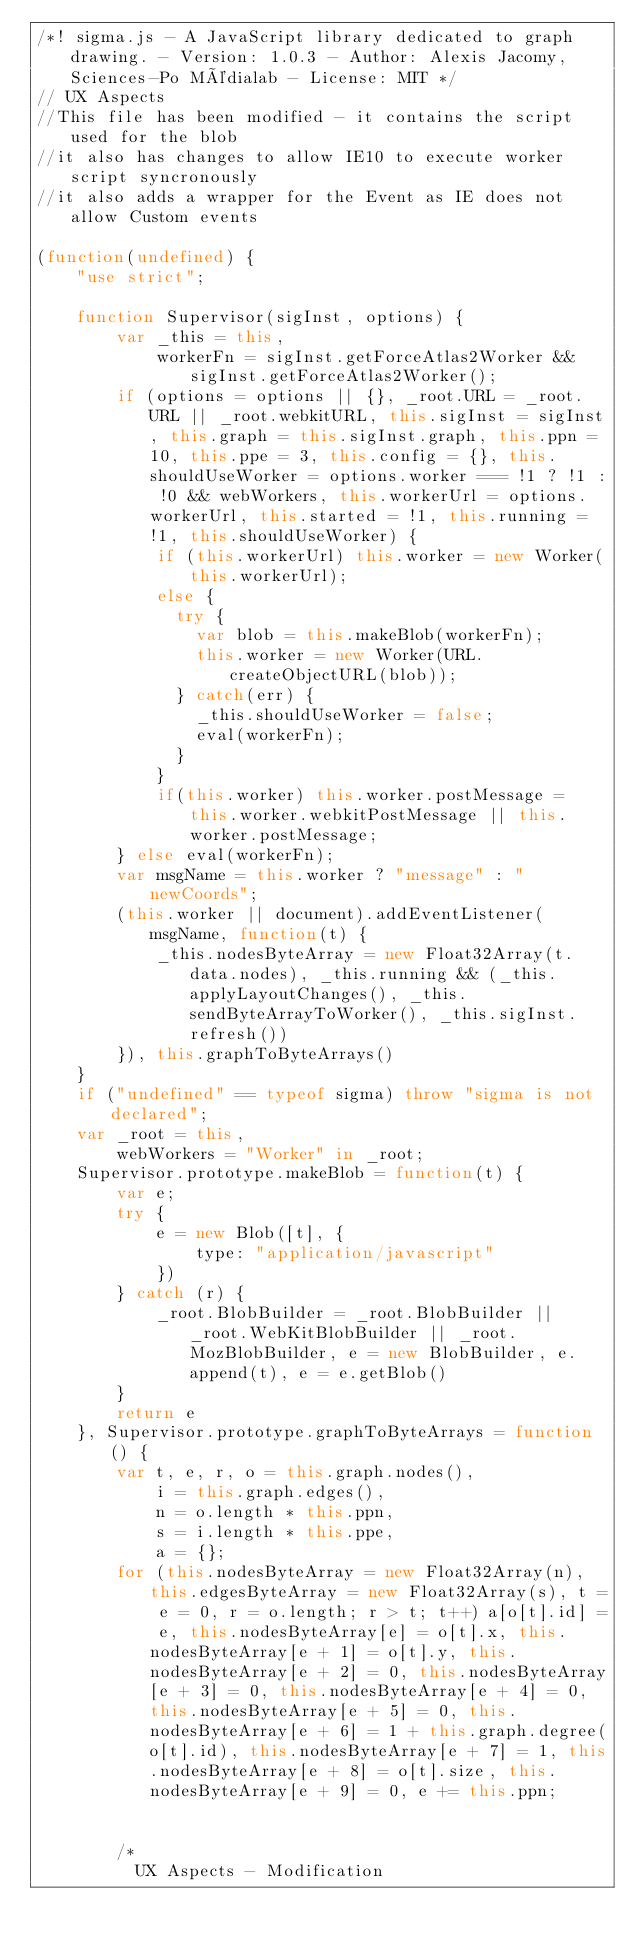<code> <loc_0><loc_0><loc_500><loc_500><_JavaScript_>/*! sigma.js - A JavaScript library dedicated to graph drawing. - Version: 1.0.3 - Author: Alexis Jacomy, Sciences-Po Médialab - License: MIT */
// UX Aspects
//This file has been modified - it contains the script used for the blob
//it also has changes to allow IE10 to execute worker script syncronously
//it also adds a wrapper for the Event as IE does not allow Custom events

(function(undefined) {
    "use strict";

    function Supervisor(sigInst, options) {
        var _this = this,
            workerFn = sigInst.getForceAtlas2Worker && sigInst.getForceAtlas2Worker();
        if (options = options || {}, _root.URL = _root.URL || _root.webkitURL, this.sigInst = sigInst, this.graph = this.sigInst.graph, this.ppn = 10, this.ppe = 3, this.config = {}, this.shouldUseWorker = options.worker === !1 ? !1 : !0 && webWorkers, this.workerUrl = options.workerUrl, this.started = !1, this.running = !1, this.shouldUseWorker) {
            if (this.workerUrl) this.worker = new Worker(this.workerUrl);
            else {
              try {
                var blob = this.makeBlob(workerFn);
                this.worker = new Worker(URL.createObjectURL(blob));
              } catch(err) {
                _this.shouldUseWorker = false;
                eval(workerFn);
              }
            }
            if(this.worker) this.worker.postMessage = this.worker.webkitPostMessage || this.worker.postMessage;
        } else eval(workerFn);
        var msgName = this.worker ? "message" : "newCoords";
        (this.worker || document).addEventListener(msgName, function(t) {
            _this.nodesByteArray = new Float32Array(t.data.nodes), _this.running && (_this.applyLayoutChanges(), _this.sendByteArrayToWorker(), _this.sigInst.refresh())
        }), this.graphToByteArrays()
    }
    if ("undefined" == typeof sigma) throw "sigma is not declared";
    var _root = this,
        webWorkers = "Worker" in _root;
    Supervisor.prototype.makeBlob = function(t) {
        var e;
        try {
            e = new Blob([t], {
                type: "application/javascript"
            })
        } catch (r) {
            _root.BlobBuilder = _root.BlobBuilder || _root.WebKitBlobBuilder || _root.MozBlobBuilder, e = new BlobBuilder, e.append(t), e = e.getBlob()
        }
        return e
    }, Supervisor.prototype.graphToByteArrays = function() {
        var t, e, r, o = this.graph.nodes(),
            i = this.graph.edges(),
            n = o.length * this.ppn,
            s = i.length * this.ppe,
            a = {};
        for (this.nodesByteArray = new Float32Array(n), this.edgesByteArray = new Float32Array(s), t = e = 0, r = o.length; r > t; t++) a[o[t].id] = e, this.nodesByteArray[e] = o[t].x, this.nodesByteArray[e + 1] = o[t].y, this.nodesByteArray[e + 2] = 0, this.nodesByteArray[e + 3] = 0, this.nodesByteArray[e + 4] = 0, this.nodesByteArray[e + 5] = 0, this.nodesByteArray[e + 6] = 1 + this.graph.degree(o[t].id), this.nodesByteArray[e + 7] = 1, this.nodesByteArray[e + 8] = o[t].size, this.nodesByteArray[e + 9] = 0, e += this.ppn;


        /*
          UX Aspects - Modification</code> 